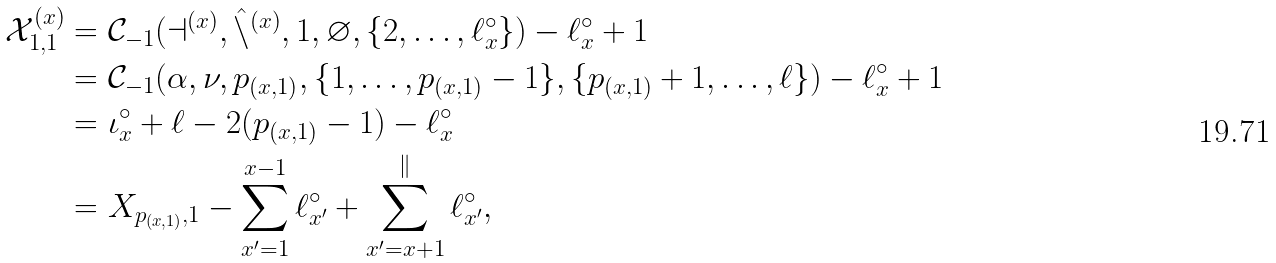<formula> <loc_0><loc_0><loc_500><loc_500>\mathcal { X } _ { 1 , 1 } ^ { ( x ) } & = \mathcal { C } _ { - 1 } ( \mathcal { a } ^ { ( x ) } , \hat { \mathcal { n } } ^ { ( x ) } , 1 , \varnothing , \{ 2 , \dots , \ell ^ { \circ } _ { x } \} ) - \ell ^ { \circ } _ { x } + 1 \\ & = \mathcal { C } _ { - 1 } ( \alpha , \nu , p _ { ( x , 1 ) } , \{ 1 , \dots , p _ { ( x , 1 ) } - 1 \} , \{ p _ { ( x , 1 ) } + 1 , \dots , \ell \} ) - \ell ^ { \circ } _ { x } + 1 \\ & = \iota ^ { \circ } _ { x } + \ell - 2 ( p _ { ( x , 1 ) } - 1 ) - \ell ^ { \circ } _ { x } \\ & = X _ { p _ { ( x , 1 ) } , 1 } - \sum _ { x ^ { \prime } = 1 } ^ { x - 1 } \ell ^ { \circ } _ { x ^ { \prime } } + \sum _ { x ^ { \prime } = x + 1 } ^ { \mathcal { k } } \ell ^ { \circ } _ { x ^ { \prime } } ,</formula> 